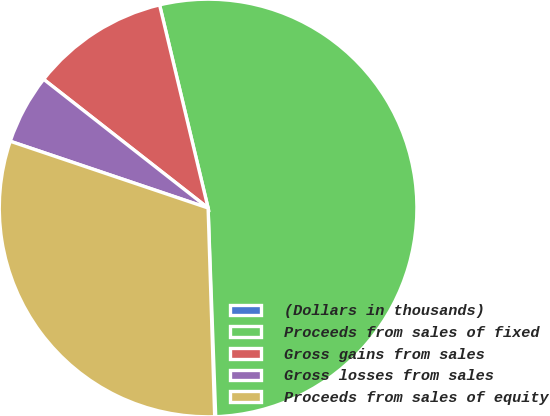Convert chart. <chart><loc_0><loc_0><loc_500><loc_500><pie_chart><fcel>(Dollars in thousands)<fcel>Proceeds from sales of fixed<fcel>Gross gains from sales<fcel>Gross losses from sales<fcel>Proceeds from sales of equity<nl><fcel>0.08%<fcel>53.15%<fcel>10.7%<fcel>5.39%<fcel>30.68%<nl></chart> 